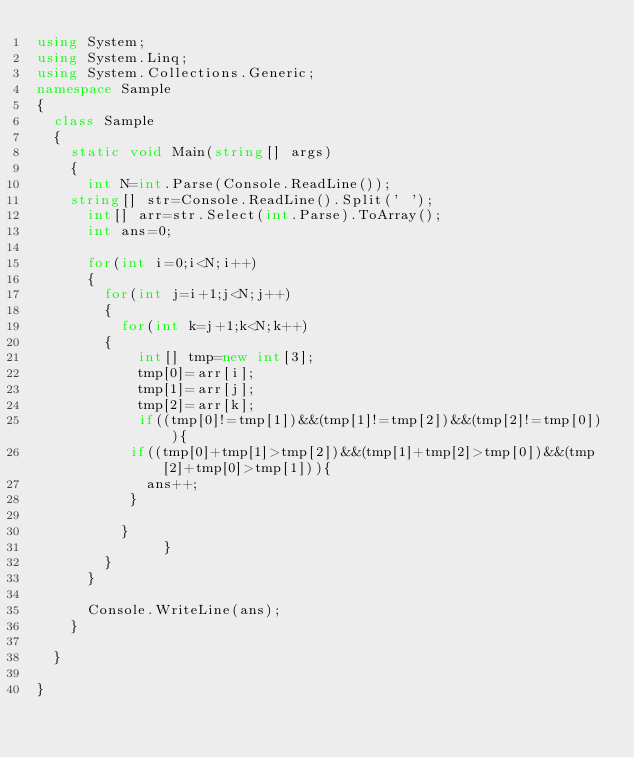Convert code to text. <code><loc_0><loc_0><loc_500><loc_500><_C#_>using System;
using System.Linq;
using System.Collections.Generic;
namespace Sample
{
  class Sample
  {
    static void Main(string[] args)
    {
      int N=int.Parse(Console.ReadLine());
    string[] str=Console.ReadLine().Split(' ');
      int[] arr=str.Select(int.Parse).ToArray();
      int ans=0;

      for(int i=0;i<N;i++)
      {
        for(int j=i+1;j<N;j++)
        {
          for(int k=j+1;k<N;k++)
        {
            int[] tmp=new int[3];
            tmp[0]=arr[i];
            tmp[1]=arr[j];
            tmp[2]=arr[k];
            if((tmp[0]!=tmp[1])&&(tmp[1]!=tmp[2])&&(tmp[2]!=tmp[0])){
           if((tmp[0]+tmp[1]>tmp[2])&&(tmp[1]+tmp[2]>tmp[0])&&(tmp[2]+tmp[0]>tmp[1])){
             ans++;
           }
      
          }
               }
        }
      }
      
      Console.WriteLine(ans);
    }
    
  }

}
</code> 